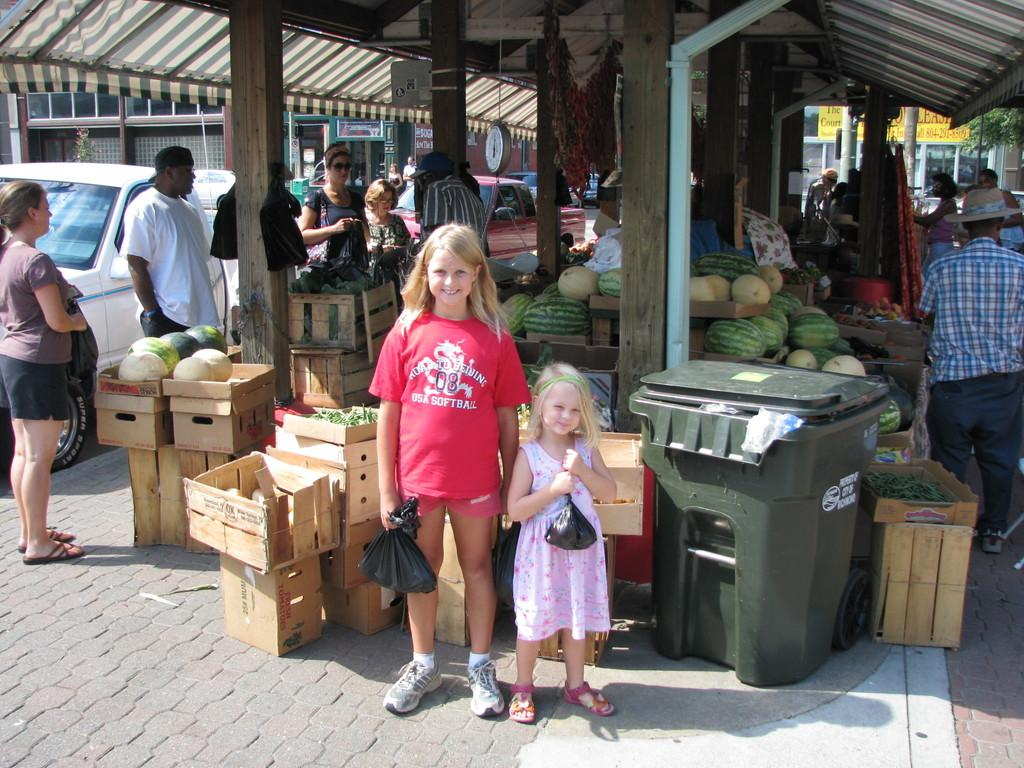Provide a one-sentence caption for the provided image. A girl wears a red USA Softball t-shirt. 